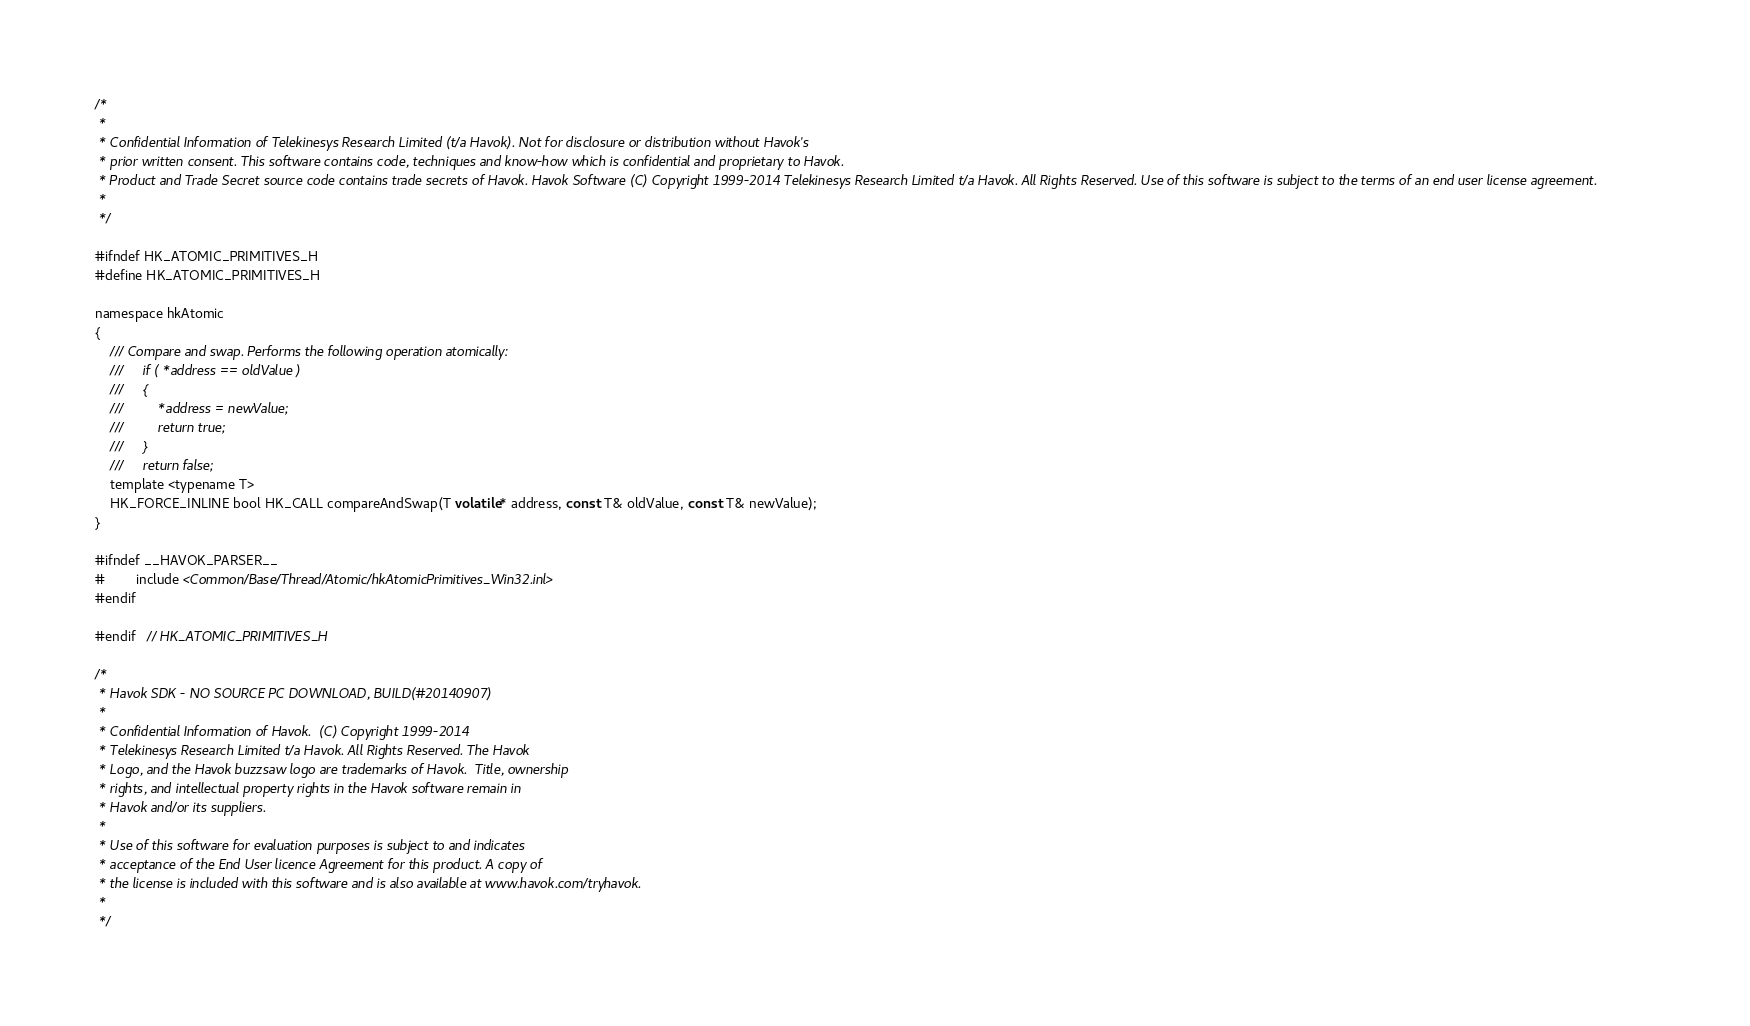Convert code to text. <code><loc_0><loc_0><loc_500><loc_500><_C_>/*
 *
 * Confidential Information of Telekinesys Research Limited (t/a Havok). Not for disclosure or distribution without Havok's
 * prior written consent. This software contains code, techniques and know-how which is confidential and proprietary to Havok.
 * Product and Trade Secret source code contains trade secrets of Havok. Havok Software (C) Copyright 1999-2014 Telekinesys Research Limited t/a Havok. All Rights Reserved. Use of this software is subject to the terms of an end user license agreement.
 *
 */

#ifndef HK_ATOMIC_PRIMITIVES_H
#define HK_ATOMIC_PRIMITIVES_H

namespace hkAtomic
{
	/// Compare and swap. Performs the following operation atomically:
	///		if ( *address == oldValue )
	///		{
	///			*address = newValue;
	///			return true;
	///		}
	///		return false;
	template <typename T>
	HK_FORCE_INLINE bool HK_CALL compareAndSwap(T volatile* address, const T& oldValue, const T& newValue);
}

#ifndef __HAVOK_PARSER__
#		include <Common/Base/Thread/Atomic/hkAtomicPrimitives_Win32.inl>
#endif

#endif	// HK_ATOMIC_PRIMITIVES_H

/*
 * Havok SDK - NO SOURCE PC DOWNLOAD, BUILD(#20140907)
 * 
 * Confidential Information of Havok.  (C) Copyright 1999-2014
 * Telekinesys Research Limited t/a Havok. All Rights Reserved. The Havok
 * Logo, and the Havok buzzsaw logo are trademarks of Havok.  Title, ownership
 * rights, and intellectual property rights in the Havok software remain in
 * Havok and/or its suppliers.
 * 
 * Use of this software for evaluation purposes is subject to and indicates
 * acceptance of the End User licence Agreement for this product. A copy of
 * the license is included with this software and is also available at www.havok.com/tryhavok.
 * 
 */
</code> 